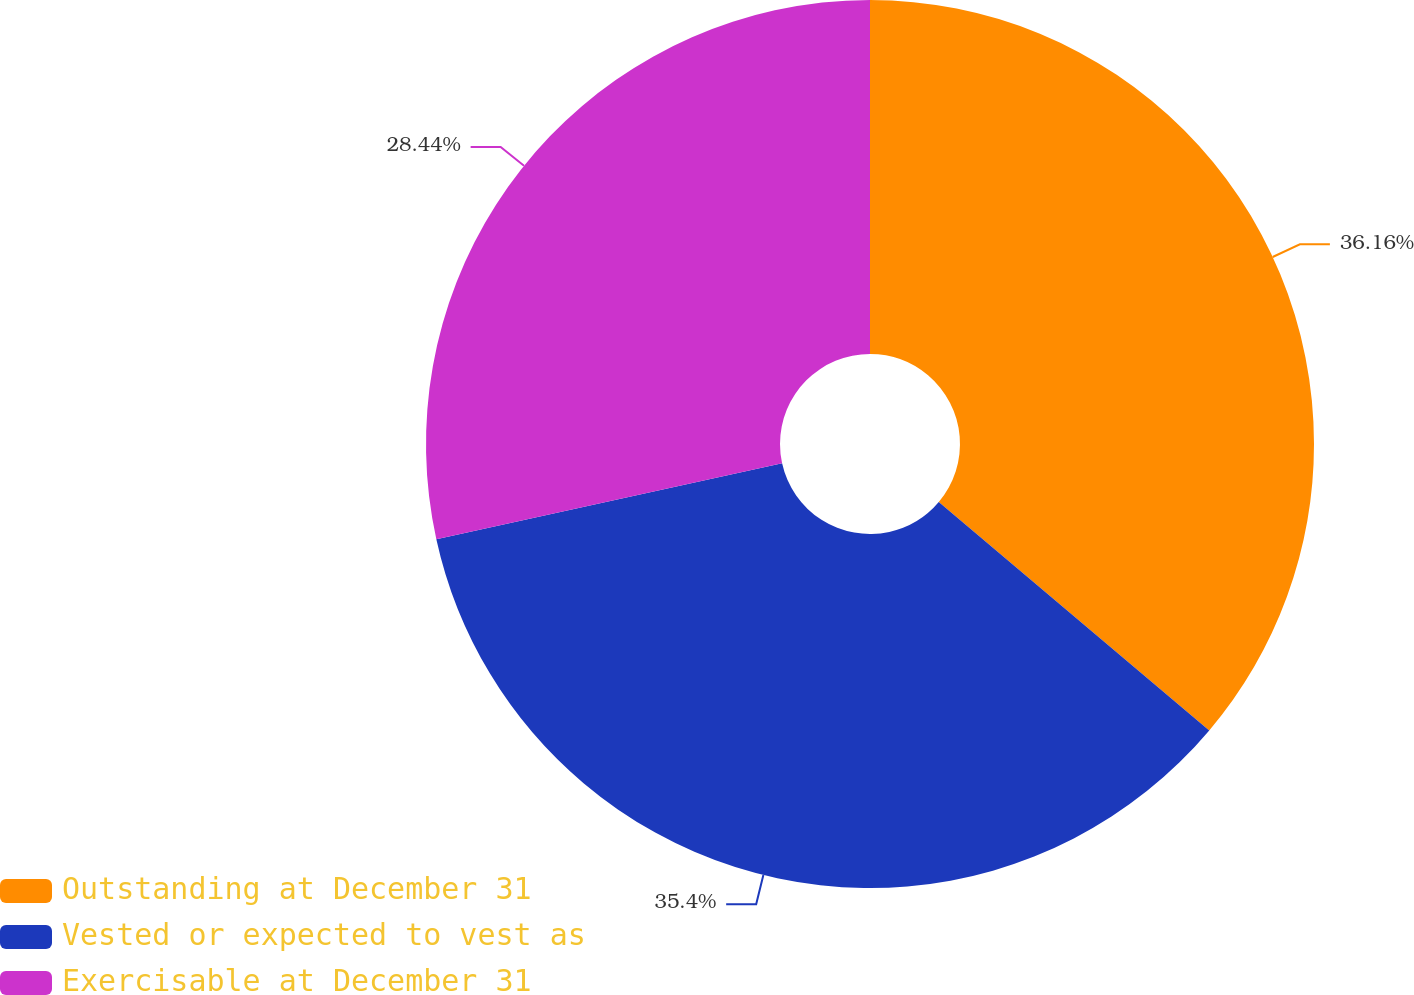Convert chart to OTSL. <chart><loc_0><loc_0><loc_500><loc_500><pie_chart><fcel>Outstanding at December 31<fcel>Vested or expected to vest as<fcel>Exercisable at December 31<nl><fcel>36.16%<fcel>35.4%<fcel>28.44%<nl></chart> 